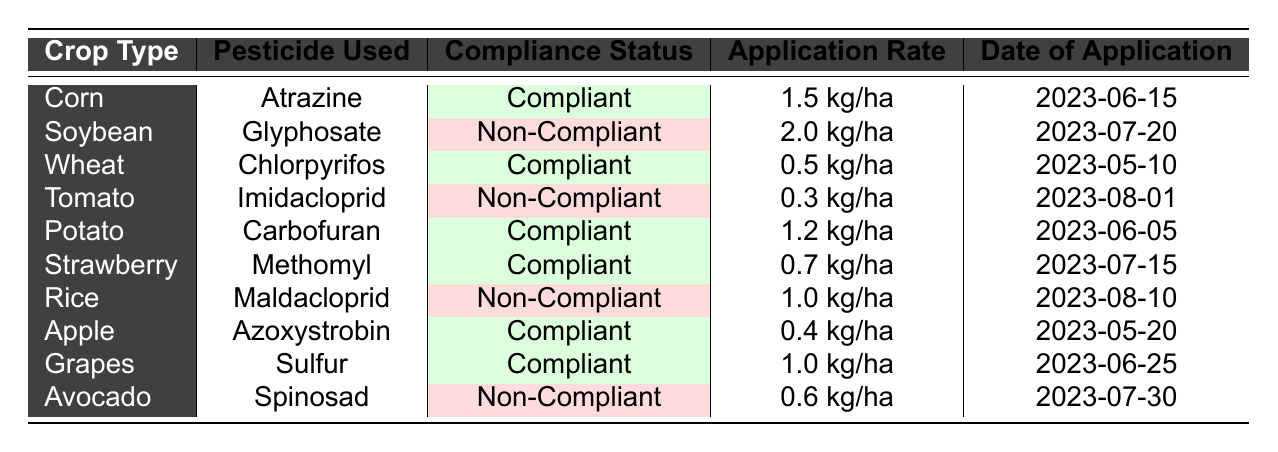What is the compliance status for Corn? According to the table, the compliance status for Corn is specifically listed as Compliant, which means it adheres to the pesticide usage standards set.
Answer: Compliant Which crop has the highest application rate of pesticide used? The table shows that the highest application rate is for Soybean, with 2.0 kg/ha. This value is higher than all other listed crops.
Answer: 2.0 kg/ha List the non-compliant crops. The table provides the compliance status for each crop. By filtering for Non-Compliant, we find Soybean, Tomato, Rice, and Avocado as the non-compliant crops.
Answer: Soybean, Tomato, Rice, Avocado What is the average application rate of compliant crops? The compliant crops are Corn (1.5 kg/ha), Wheat (0.5 kg/ha), Potato (1.2 kg/ha), Strawberry (0.7 kg/ha), Apple (0.4 kg/ha), and Grapes (1.0 kg/ha). Summing these gives 1.5 + 0.5 + 1.2 + 0.7 + 0.4 + 1.0 = 5.3. There are 6 compliant crops, so the average is 5.3 / 6 = 0.8833 kg/ha.
Answer: 0.8833 kg/ha Does Rice have a compliant status? Looking at the entry for Rice in the table, it clearly shows that the compliance status is Non-Compliant, meaning it does not meet the pesticide usage standards.
Answer: No Which pesticide was used for Tomato, and what is its compliance status? The table lists Tomato with the pesticide used as Imidacloprid. The compliance status for this entry is Non-Compliant, indicating that it did not meet the required standards.
Answer: Imidacloprid, Non-Compliant How many crops are compliant and how many are non-compliant? By reviewing the table, we can count the compliant crops: Corn, Wheat, Potato, Strawberry, Apple, and Grapes, totaling 6. The non-compliant crops are Soybean, Tomato, Rice, and Avocado, totaling 4. Thus, there are 6 compliant and 4 non-compliant crops.
Answer: 6 compliant, 4 non-compliant Which crop has the lowest application rate, and is it compliant? From the listed application rates, Tomato has the lowest at 0.3 kg/ha. Checking the compliance status reveals that it is Non-Compliant, failing to meet the safety standards.
Answer: Tomato, Non-Compliant 